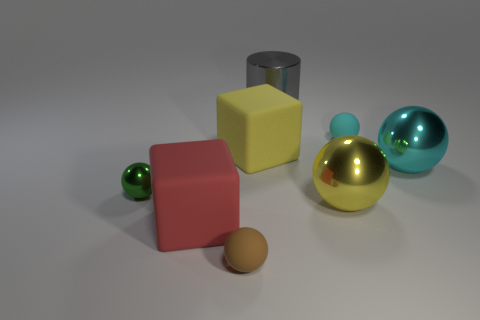Subtract all green balls. How many balls are left? 4 Subtract all tiny shiny balls. How many balls are left? 4 Subtract all green balls. Subtract all blue blocks. How many balls are left? 4 Add 1 cyan metallic spheres. How many objects exist? 9 Subtract all balls. How many objects are left? 3 Subtract all metal cylinders. Subtract all tiny objects. How many objects are left? 4 Add 3 red blocks. How many red blocks are left? 4 Add 2 small brown shiny spheres. How many small brown shiny spheres exist? 2 Subtract 1 gray cylinders. How many objects are left? 7 